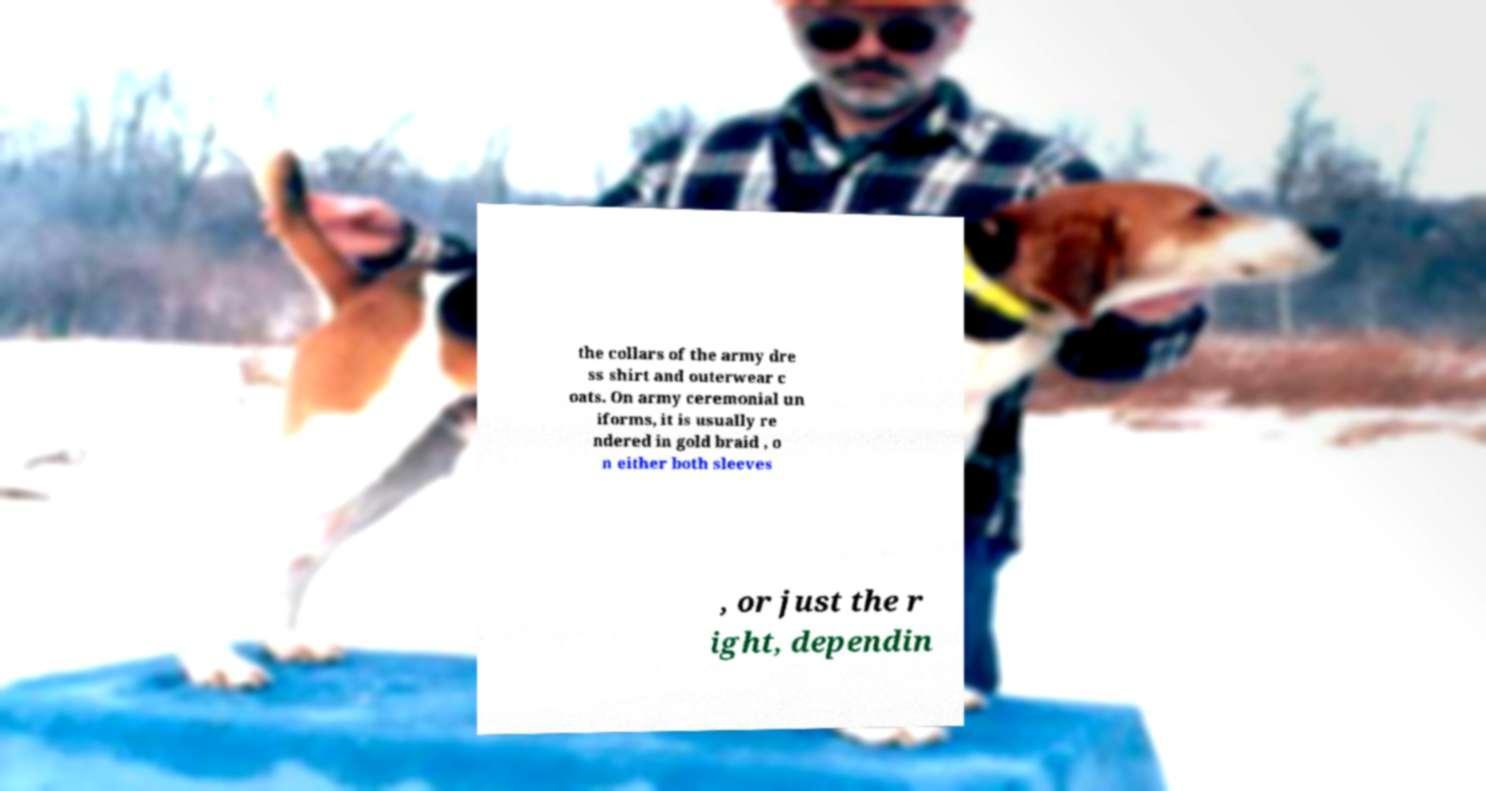I need the written content from this picture converted into text. Can you do that? the collars of the army dre ss shirt and outerwear c oats. On army ceremonial un iforms, it is usually re ndered in gold braid , o n either both sleeves , or just the r ight, dependin 